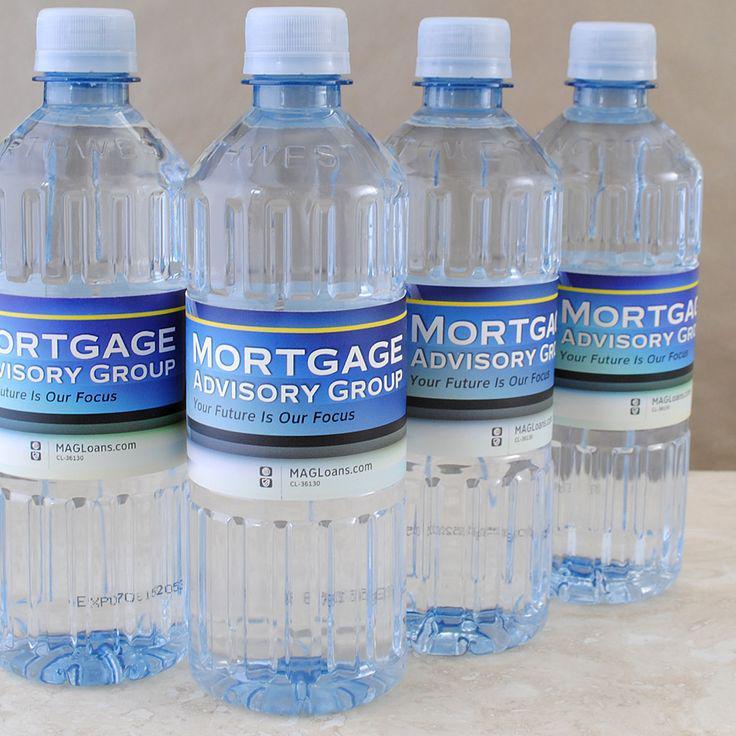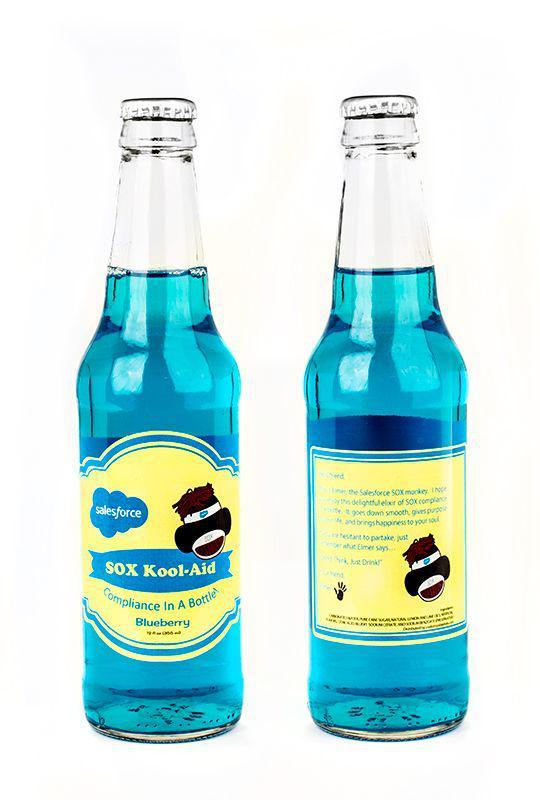The first image is the image on the left, the second image is the image on the right. For the images shown, is this caption "One image contains exactly two bottles displayed level and head-on, and the other image includes at least four identical bottles with identical labels." true? Answer yes or no. Yes. The first image is the image on the left, the second image is the image on the right. Analyze the images presented: Is the assertion "The left and right image contains a total of six bottles." valid? Answer yes or no. Yes. 